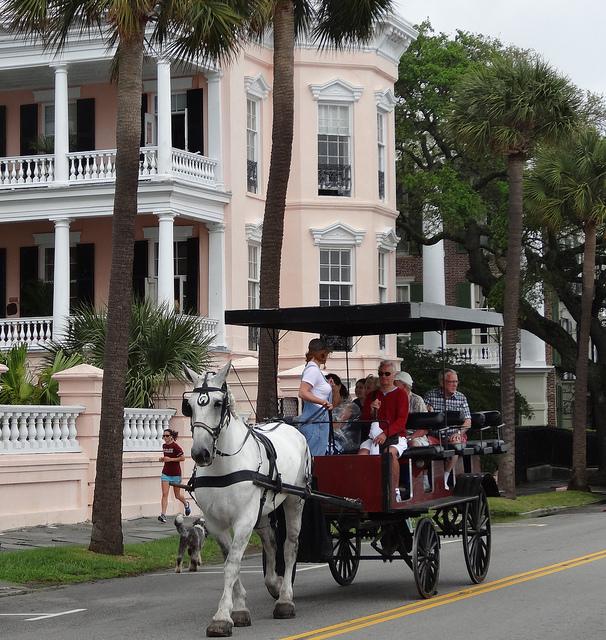What color is the horse?
Concise answer only. White. What color shorts is the jogger wearing?
Concise answer only. Blue. Are these students?
Be succinct. No. Do you see any small animals?
Concise answer only. Yes. Is this where the party is?
Give a very brief answer. No. 